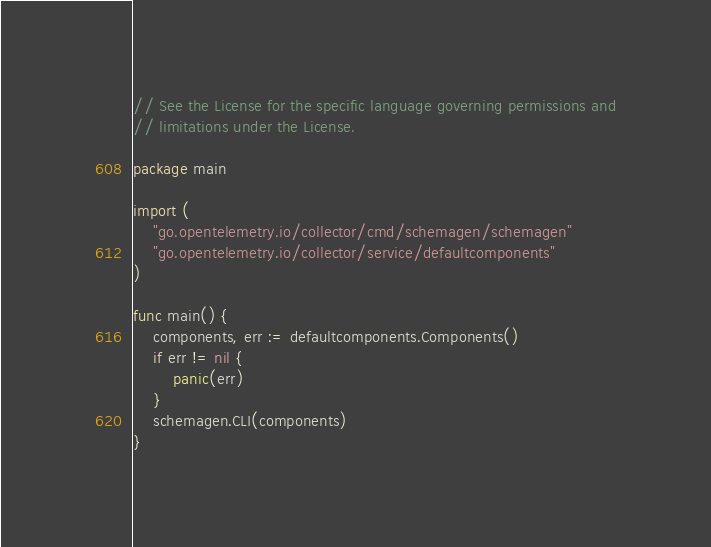<code> <loc_0><loc_0><loc_500><loc_500><_Go_>// See the License for the specific language governing permissions and
// limitations under the License.

package main

import (
	"go.opentelemetry.io/collector/cmd/schemagen/schemagen"
	"go.opentelemetry.io/collector/service/defaultcomponents"
)

func main() {
	components, err := defaultcomponents.Components()
	if err != nil {
		panic(err)
	}
	schemagen.CLI(components)
}
</code> 